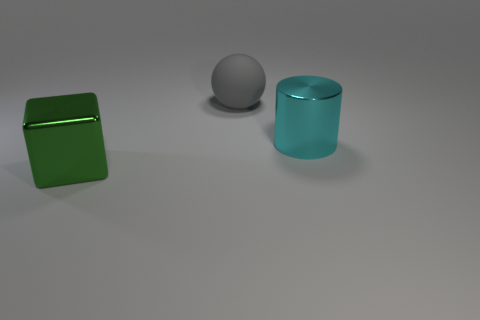Are there fewer big green things that are behind the cyan metal cylinder than objects?
Make the answer very short. Yes. How many spheres are the same color as the metal cylinder?
Offer a terse response. 0. Is there anything else that has the same shape as the big gray matte object?
Offer a very short reply. No. Are there any large metallic things right of the large metal object that is to the left of the large shiny thing that is behind the large green shiny thing?
Your response must be concise. Yes. How many blocks have the same material as the big cylinder?
Make the answer very short. 1. The large metal thing behind the shiny object left of the metallic thing to the right of the large sphere is what color?
Your answer should be compact. Cyan. Are there the same number of big cyan cylinders that are on the left side of the large green metal thing and matte balls left of the large cyan object?
Offer a very short reply. No. How many rubber objects are either small red things or green cubes?
Your answer should be very brief. 0. What number of objects are large cylinders or shiny objects that are on the right side of the gray object?
Your answer should be compact. 1. What material is the green block that is the same size as the cyan thing?
Your answer should be very brief. Metal. 